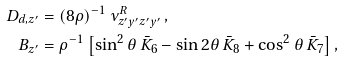<formula> <loc_0><loc_0><loc_500><loc_500>D _ { d , z ^ { \prime } } & = ( 8 \rho ) ^ { - 1 } \, \nu _ { z ^ { \prime } y ^ { \prime } z ^ { \prime } y ^ { \prime } } ^ { R } \, , \\ B _ { z ^ { \prime } } & = \rho ^ { - 1 } \left [ \sin ^ { 2 } \theta \, \bar { K } _ { 6 } - \sin 2 \theta \, \bar { K } _ { 8 } + \cos ^ { 2 } \theta \, \bar { K } _ { 7 } \right ] ,</formula> 